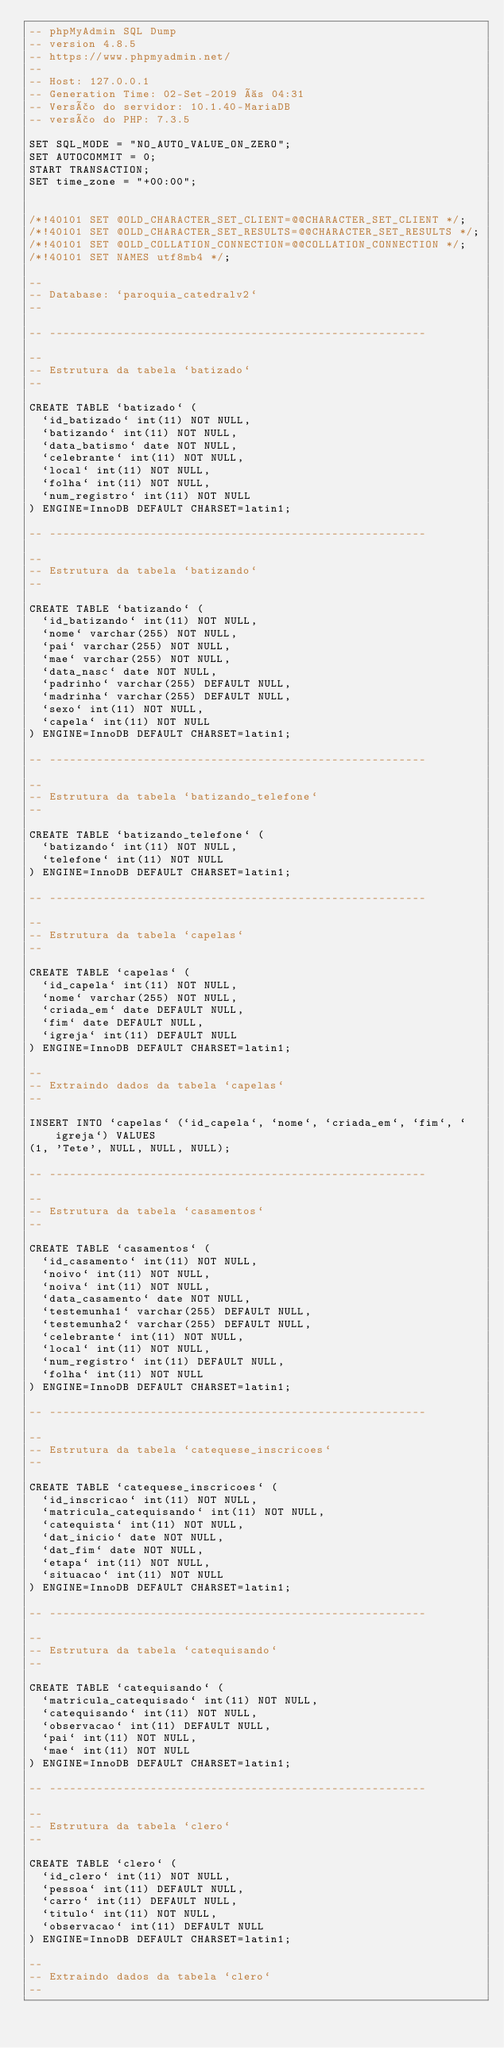Convert code to text. <code><loc_0><loc_0><loc_500><loc_500><_SQL_>-- phpMyAdmin SQL Dump
-- version 4.8.5
-- https://www.phpmyadmin.net/
--
-- Host: 127.0.0.1
-- Generation Time: 02-Set-2019 às 04:31
-- Versão do servidor: 10.1.40-MariaDB
-- versão do PHP: 7.3.5

SET SQL_MODE = "NO_AUTO_VALUE_ON_ZERO";
SET AUTOCOMMIT = 0;
START TRANSACTION;
SET time_zone = "+00:00";


/*!40101 SET @OLD_CHARACTER_SET_CLIENT=@@CHARACTER_SET_CLIENT */;
/*!40101 SET @OLD_CHARACTER_SET_RESULTS=@@CHARACTER_SET_RESULTS */;
/*!40101 SET @OLD_COLLATION_CONNECTION=@@COLLATION_CONNECTION */;
/*!40101 SET NAMES utf8mb4 */;

--
-- Database: `paroquia_catedralv2`
--

-- --------------------------------------------------------

--
-- Estrutura da tabela `batizado`
--

CREATE TABLE `batizado` (
  `id_batizado` int(11) NOT NULL,
  `batizando` int(11) NOT NULL,
  `data_batismo` date NOT NULL,
  `celebrante` int(11) NOT NULL,
  `local` int(11) NOT NULL,
  `folha` int(11) NOT NULL,
  `num_registro` int(11) NOT NULL
) ENGINE=InnoDB DEFAULT CHARSET=latin1;

-- --------------------------------------------------------

--
-- Estrutura da tabela `batizando`
--

CREATE TABLE `batizando` (
  `id_batizando` int(11) NOT NULL,
  `nome` varchar(255) NOT NULL,
  `pai` varchar(255) NOT NULL,
  `mae` varchar(255) NOT NULL,
  `data_nasc` date NOT NULL,
  `padrinho` varchar(255) DEFAULT NULL,
  `madrinha` varchar(255) DEFAULT NULL,
  `sexo` int(11) NOT NULL,
  `capela` int(11) NOT NULL
) ENGINE=InnoDB DEFAULT CHARSET=latin1;

-- --------------------------------------------------------

--
-- Estrutura da tabela `batizando_telefone`
--

CREATE TABLE `batizando_telefone` (
  `batizando` int(11) NOT NULL,
  `telefone` int(11) NOT NULL
) ENGINE=InnoDB DEFAULT CHARSET=latin1;

-- --------------------------------------------------------

--
-- Estrutura da tabela `capelas`
--

CREATE TABLE `capelas` (
  `id_capela` int(11) NOT NULL,
  `nome` varchar(255) NOT NULL,
  `criada_em` date DEFAULT NULL,
  `fim` date DEFAULT NULL,
  `igreja` int(11) DEFAULT NULL
) ENGINE=InnoDB DEFAULT CHARSET=latin1;

--
-- Extraindo dados da tabela `capelas`
--

INSERT INTO `capelas` (`id_capela`, `nome`, `criada_em`, `fim`, `igreja`) VALUES
(1, 'Tete', NULL, NULL, NULL);

-- --------------------------------------------------------

--
-- Estrutura da tabela `casamentos`
--

CREATE TABLE `casamentos` (
  `id_casamento` int(11) NOT NULL,
  `noivo` int(11) NOT NULL,
  `noiva` int(11) NOT NULL,
  `data_casamento` date NOT NULL,
  `testemunha1` varchar(255) DEFAULT NULL,
  `testemunha2` varchar(255) DEFAULT NULL,
  `celebrante` int(11) NOT NULL,
  `local` int(11) NOT NULL,
  `num_registro` int(11) DEFAULT NULL,
  `folha` int(11) NOT NULL
) ENGINE=InnoDB DEFAULT CHARSET=latin1;

-- --------------------------------------------------------

--
-- Estrutura da tabela `catequese_inscricoes`
--

CREATE TABLE `catequese_inscricoes` (
  `id_inscricao` int(11) NOT NULL,
  `matricula_catequisando` int(11) NOT NULL,
  `catequista` int(11) NOT NULL,
  `dat_inicio` date NOT NULL,
  `dat_fim` date NOT NULL,
  `etapa` int(11) NOT NULL,
  `situacao` int(11) NOT NULL
) ENGINE=InnoDB DEFAULT CHARSET=latin1;

-- --------------------------------------------------------

--
-- Estrutura da tabela `catequisando`
--

CREATE TABLE `catequisando` (
  `matricula_catequisado` int(11) NOT NULL,
  `catequisando` int(11) NOT NULL,
  `observacao` int(11) DEFAULT NULL,
  `pai` int(11) NOT NULL,
  `mae` int(11) NOT NULL
) ENGINE=InnoDB DEFAULT CHARSET=latin1;

-- --------------------------------------------------------

--
-- Estrutura da tabela `clero`
--

CREATE TABLE `clero` (
  `id_clero` int(11) NOT NULL,
  `pessoa` int(11) DEFAULT NULL,
  `carro` int(11) DEFAULT NULL,
  `titulo` int(11) NOT NULL,
  `observacao` int(11) DEFAULT NULL
) ENGINE=InnoDB DEFAULT CHARSET=latin1;

--
-- Extraindo dados da tabela `clero`
--
</code> 